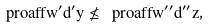Convert formula to latex. <formula><loc_0><loc_0><loc_500><loc_500>\ p r o a f f { w ^ { \prime } } { d ^ { \prime } } { y } \not \leq \ p r o a f f { w ^ { \prime \prime } } { d ^ { \prime \prime } } { z } ,</formula> 